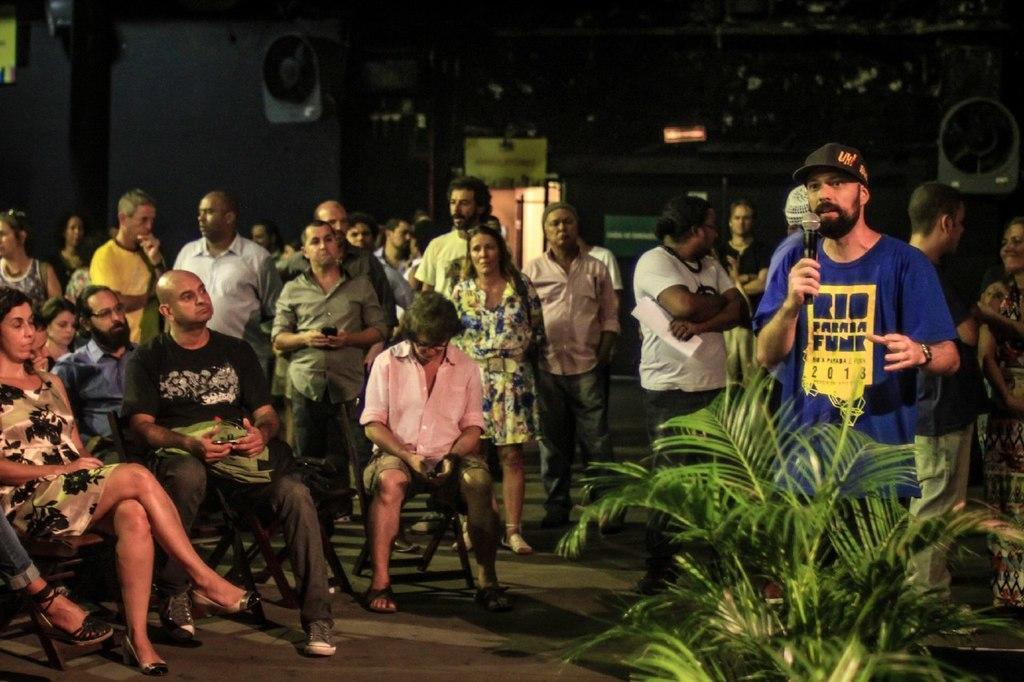In one or two sentences, can you explain what this image depicts? Background portion of the picture is dark. We can see few objects. In this picture we can see people. Few people are sitting and few people are standing. On the right side of the picture we can see a plant and we can see a man wearing a cap and standing. We can see he is holding a microphone. 